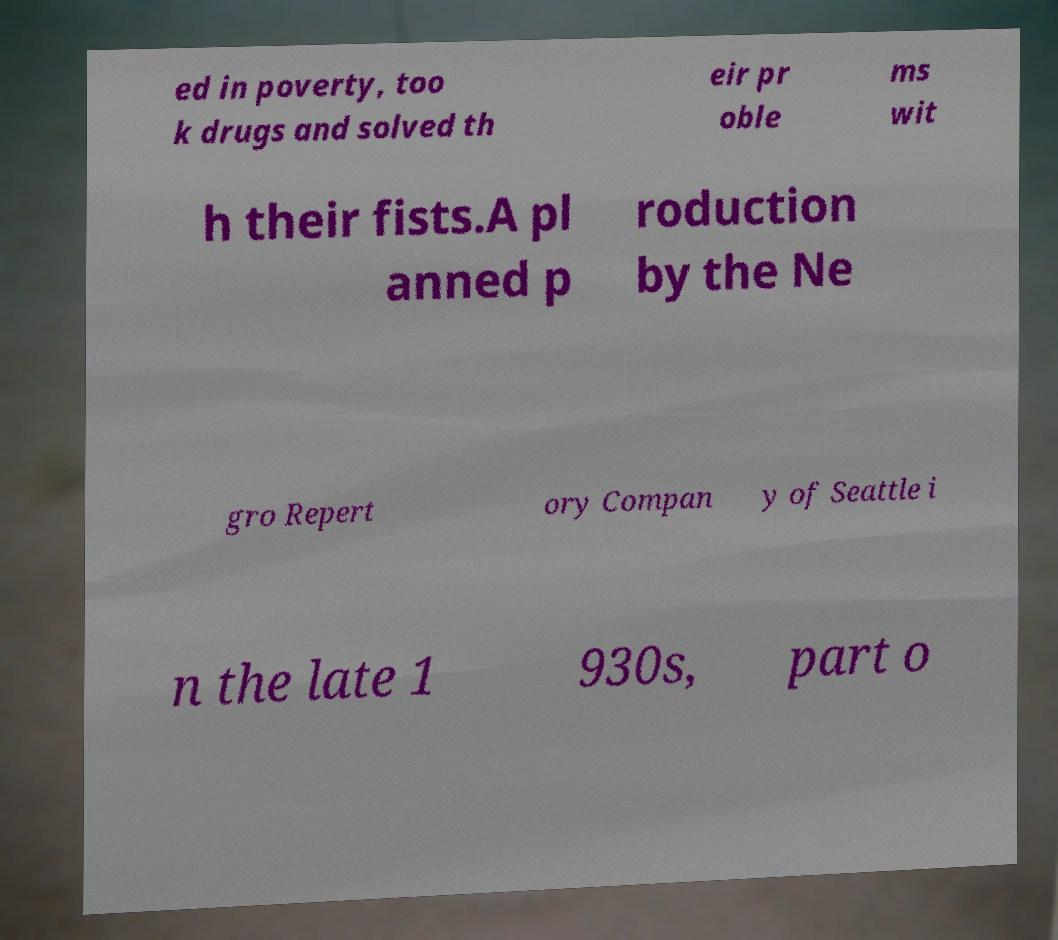Could you assist in decoding the text presented in this image and type it out clearly? ed in poverty, too k drugs and solved th eir pr oble ms wit h their fists.A pl anned p roduction by the Ne gro Repert ory Compan y of Seattle i n the late 1 930s, part o 